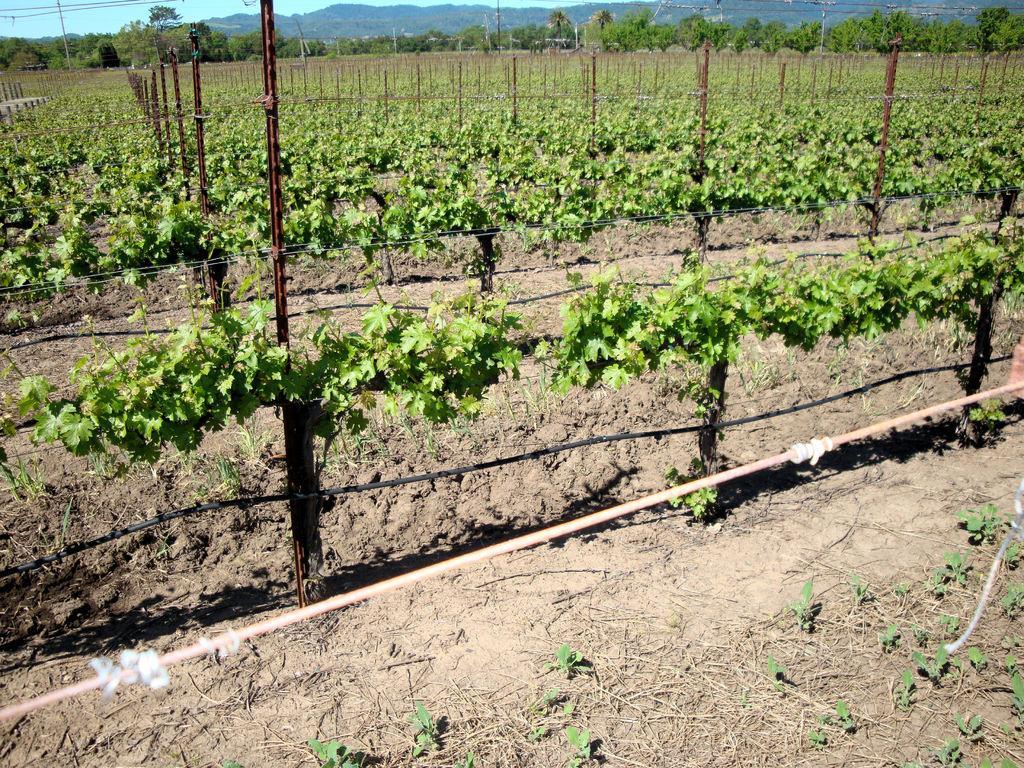Can you describe this image briefly? In this image we can see some farmlands, there are some plants, poles, fencing and in the background of the image there are some trees and mountains. 